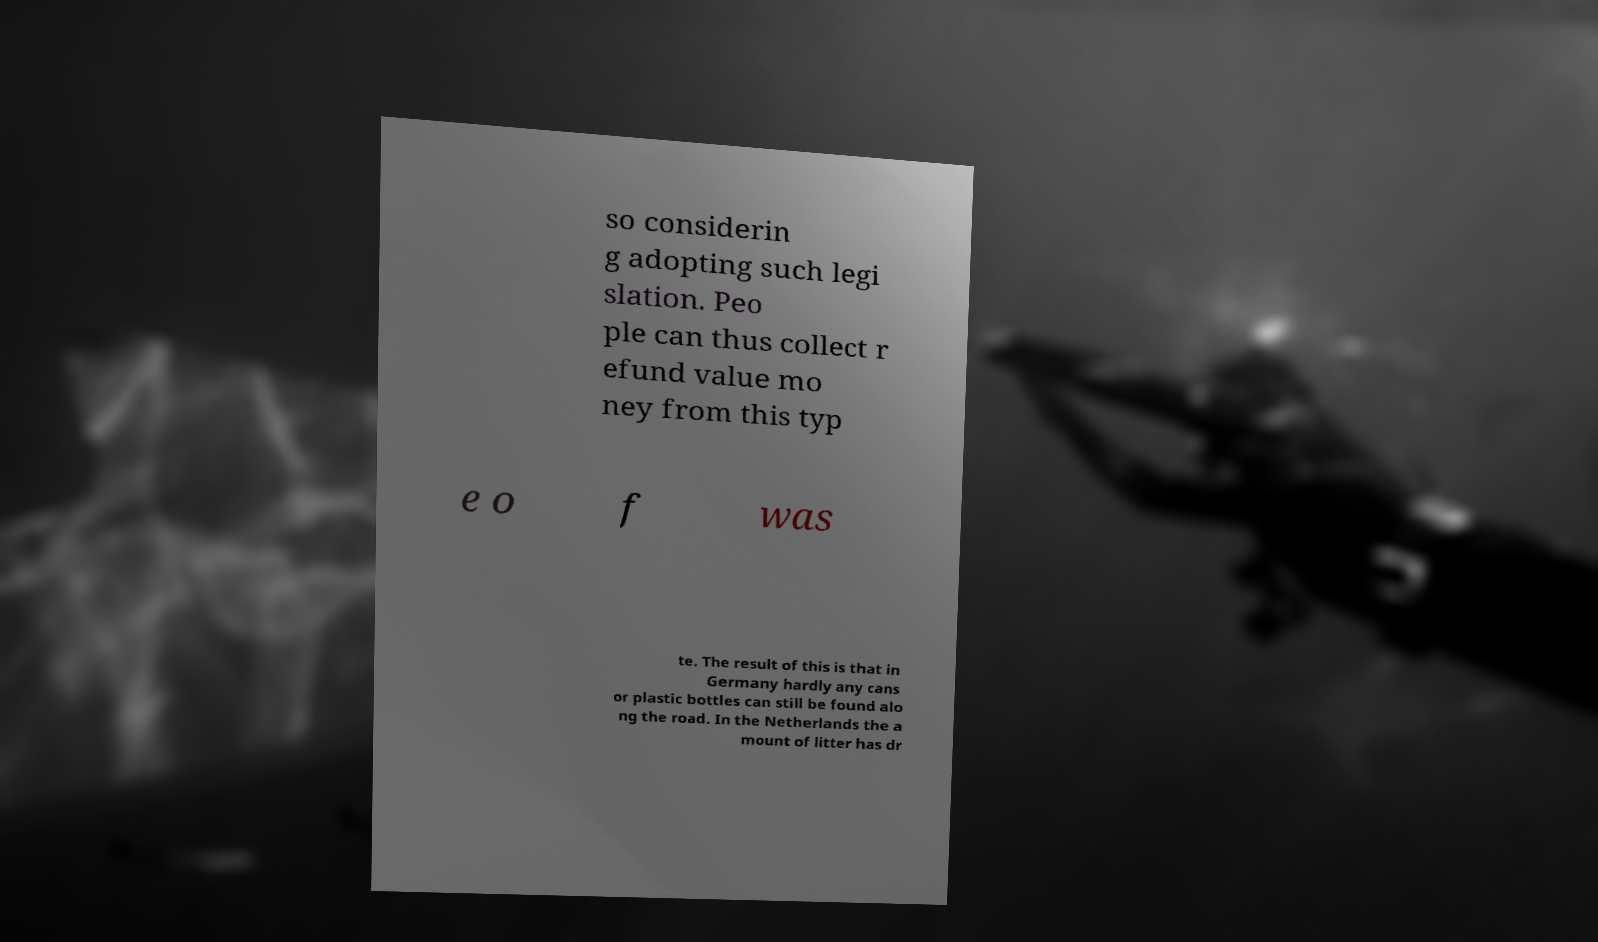Can you accurately transcribe the text from the provided image for me? so considerin g adopting such legi slation. Peo ple can thus collect r efund value mo ney from this typ e o f was te. The result of this is that in Germany hardly any cans or plastic bottles can still be found alo ng the road. In the Netherlands the a mount of litter has dr 